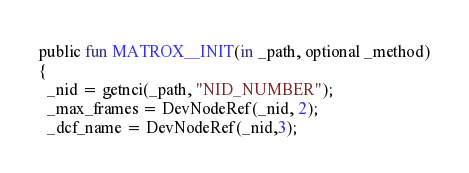Convert code to text. <code><loc_0><loc_0><loc_500><loc_500><_SML_>public fun MATROX__INIT(in _path, optional _method)
{
  _nid = getnci(_path, "NID_NUMBER");
  _max_frames = DevNodeRef(_nid, 2);
  _dcf_name = DevNodeRef(_nid,3);</code> 